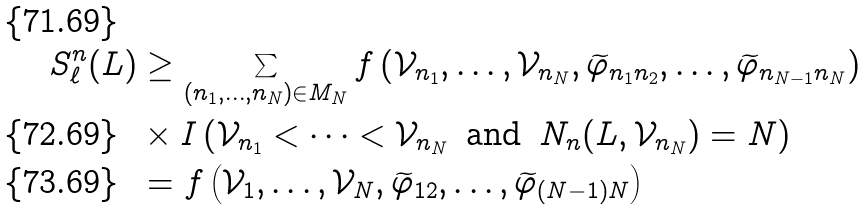Convert formula to latex. <formula><loc_0><loc_0><loc_500><loc_500>S _ { \ell } ^ { n } ( L ) & \geq \sum _ { ( n _ { 1 } , \dots , n _ { N } ) \in M _ { N } } f \left ( \mathcal { V } _ { n _ { 1 } } , \dots , \mathcal { V } _ { n _ { N } } , \widetilde { \varphi } _ { n _ { 1 } n _ { 2 } } , \dots , \widetilde { \varphi } _ { n _ { N - 1 } n _ { N } } \right ) \\ & \times I \left ( \mathcal { V } _ { n _ { 1 } } < \dots < \mathcal { V } _ { n _ { N } } \, \text { and } \, N _ { n } ( L , \mathcal { V } _ { n _ { N } } ) = N \right ) \\ & = f \left ( \mathcal { V } _ { 1 } , \dots , \mathcal { V } _ { N } , \widetilde { \varphi } _ { 1 2 } , \dots , \widetilde { \varphi } _ { ( N - 1 ) N } \right )</formula> 